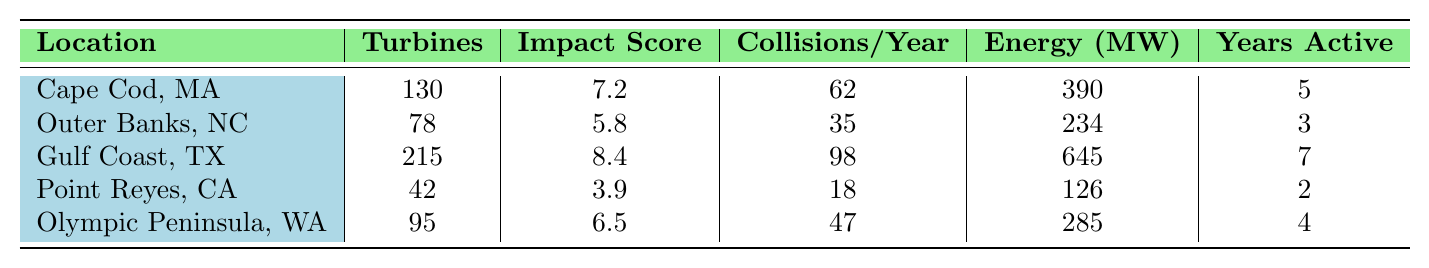What is the impact score for Gulf Coast, Texas? To find the impact score for Gulf Coast, Texas, we look at the row corresponding to that location in the table. The value for the impact score is listed directly as 8.4.
Answer: 8.4 How many turbines are installed at Cape Cod, Massachusetts? The number of turbines for Cape Cod, Massachusetts is given directly in the table. It states that there are 130 turbines installed.
Answer: 130 What location has the highest number of collision incidents per year? By reviewing the data in the "Collisions/Year" column, we see that Gulf Coast, Texas has the highest value at 98 incidents.
Answer: Gulf Coast, Texas What is the average energy output of the wind turbines across all locations? To find the average energy output, we sum all energy outputs: 390 + 234 + 645 + 126 + 285 = 1680. Then, we divide by the number of locations, which is 5. So, 1680 / 5 = 336 MW.
Answer: 336 MW Is the migration impact score for Point Reyes, California greater than 4? The migration impact score for Point Reyes is 3.9, which is less than 4. Therefore, the answer is no.
Answer: No Which location has the smallest habitat displacement area? Looking at the "Habitat Displacement Area (km²)" values, Point Reyes, California has the smallest area at 4.1 km².
Answer: Point Reyes, California What is the total number of turbines installed across all five locations? To find the total number of turbines, we sum the values: 130 + 78 + 215 + 42 + 95 = 560.
Answer: 560 How does the energy output of the Outer Banks, North Carolina compare to the Gulf Coast, Texas? The energy output for Outer Banks is 234 MW, while for Gulf Coast, it is 645 MW. Therefore, Gulf Coast has a higher energy output.
Answer: Gulf Coast has a higher energy output What is the ratio of collision incidents per year to turbine count for Olympic Peninsula, Washington? For Olympic Peninsula, Washington, the collision incidents are 47 and the turbine count is 95. The ratio is 47 / 95 = 0.495.
Answer: 0.495 Which location has the lowest impact score, and what is that score? By examining the "Impact Score" column, Point Reyes, California has the lowest score at 3.9.
Answer: Point Reyes, California; 3.9 